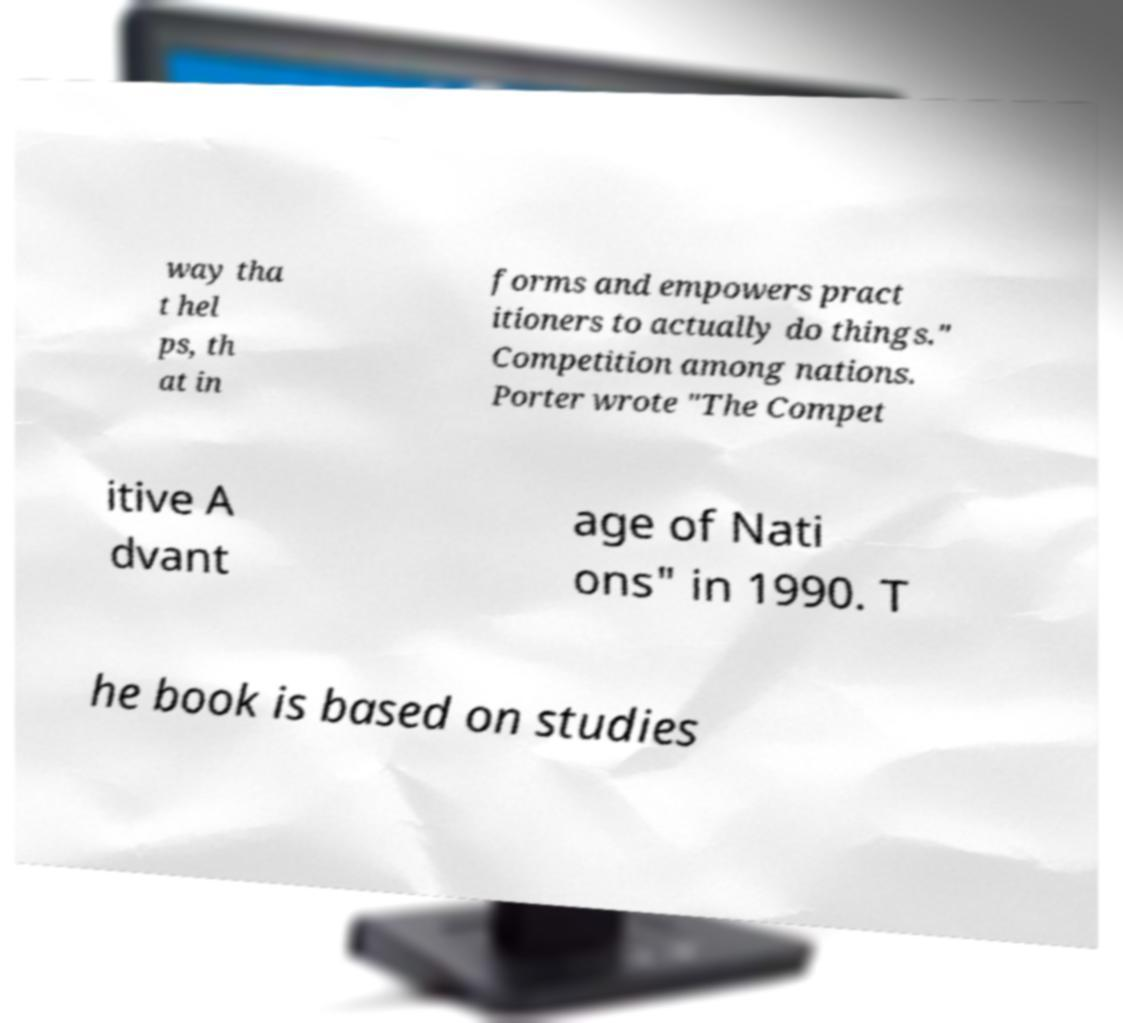Could you extract and type out the text from this image? way tha t hel ps, th at in forms and empowers pract itioners to actually do things." Competition among nations. Porter wrote "The Compet itive A dvant age of Nati ons" in 1990. T he book is based on studies 